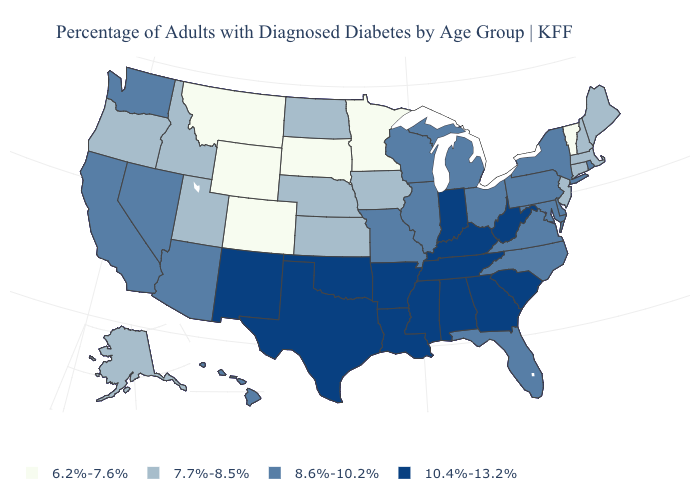Does Nevada have the same value as Connecticut?
Quick response, please. No. What is the value of Illinois?
Write a very short answer. 8.6%-10.2%. What is the value of Vermont?
Concise answer only. 6.2%-7.6%. Does the map have missing data?
Keep it brief. No. What is the value of Arkansas?
Answer briefly. 10.4%-13.2%. Which states have the highest value in the USA?
Be succinct. Alabama, Arkansas, Georgia, Indiana, Kentucky, Louisiana, Mississippi, New Mexico, Oklahoma, South Carolina, Tennessee, Texas, West Virginia. What is the highest value in the USA?
Write a very short answer. 10.4%-13.2%. Does New Jersey have the same value as South Dakota?
Keep it brief. No. What is the highest value in states that border Iowa?
Answer briefly. 8.6%-10.2%. What is the value of Montana?
Concise answer only. 6.2%-7.6%. Does Florida have the lowest value in the South?
Keep it brief. Yes. Which states have the lowest value in the USA?
Quick response, please. Colorado, Minnesota, Montana, South Dakota, Vermont, Wyoming. Does Missouri have the lowest value in the MidWest?
Keep it brief. No. What is the value of Texas?
Short answer required. 10.4%-13.2%. What is the value of Nebraska?
Quick response, please. 7.7%-8.5%. 